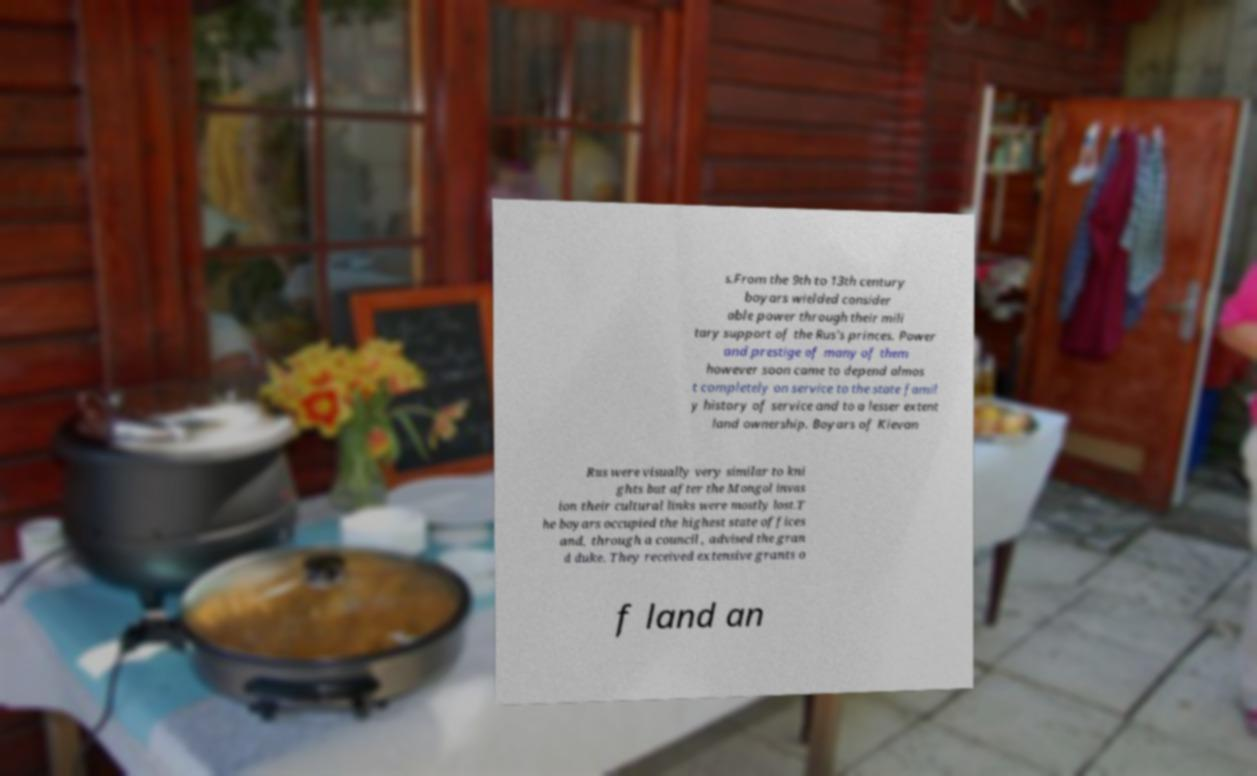I need the written content from this picture converted into text. Can you do that? s.From the 9th to 13th century boyars wielded consider able power through their mili tary support of the Rus's princes. Power and prestige of many of them however soon came to depend almos t completely on service to the state famil y history of service and to a lesser extent land ownership. Boyars of Kievan Rus were visually very similar to kni ghts but after the Mongol invas ion their cultural links were mostly lost.T he boyars occupied the highest state offices and, through a council , advised the gran d duke. They received extensive grants o f land an 